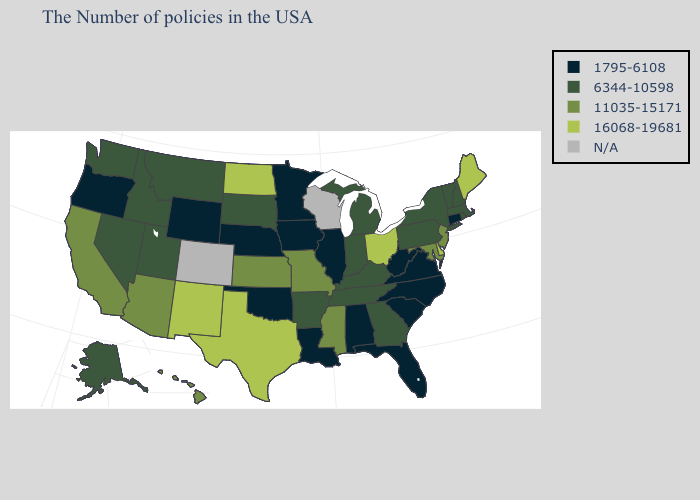What is the value of Hawaii?
Keep it brief. 11035-15171. Which states have the highest value in the USA?
Short answer required. Maine, Delaware, Ohio, Texas, North Dakota, New Mexico. Among the states that border Georgia , which have the lowest value?
Concise answer only. North Carolina, South Carolina, Florida, Alabama. Does Maine have the highest value in the Northeast?
Give a very brief answer. Yes. What is the lowest value in the USA?
Concise answer only. 1795-6108. What is the value of Arizona?
Give a very brief answer. 11035-15171. What is the value of Louisiana?
Quick response, please. 1795-6108. Which states have the lowest value in the Northeast?
Short answer required. Connecticut. Name the states that have a value in the range 11035-15171?
Answer briefly. New Jersey, Maryland, Mississippi, Missouri, Kansas, Arizona, California, Hawaii. What is the value of Minnesota?
Write a very short answer. 1795-6108. What is the value of Arizona?
Concise answer only. 11035-15171. What is the highest value in the MidWest ?
Give a very brief answer. 16068-19681. Does Delaware have the highest value in the South?
Be succinct. Yes. 